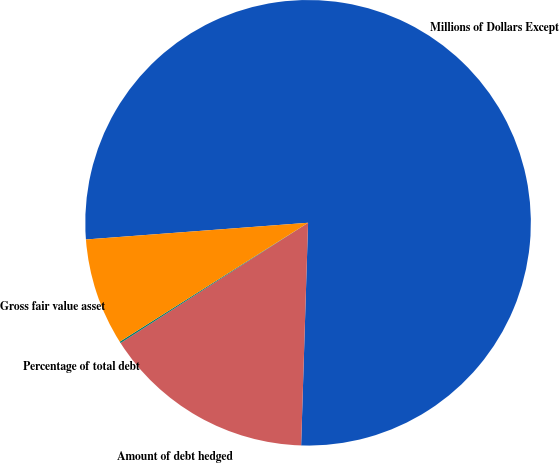Convert chart to OTSL. <chart><loc_0><loc_0><loc_500><loc_500><pie_chart><fcel>Millions of Dollars Except<fcel>Amount of debt hedged<fcel>Percentage of total debt<fcel>Gross fair value asset<nl><fcel>76.69%<fcel>15.43%<fcel>0.11%<fcel>7.77%<nl></chart> 